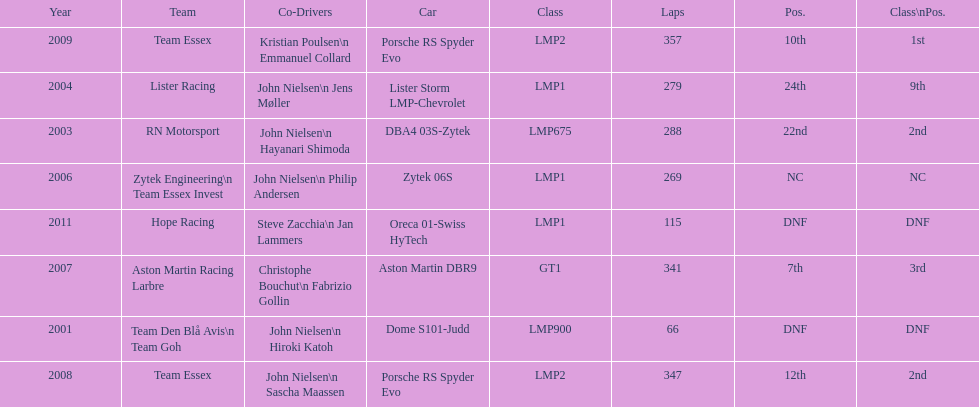Who was casper elgaard's co-driver the most often for the 24 hours of le mans? John Nielsen. 